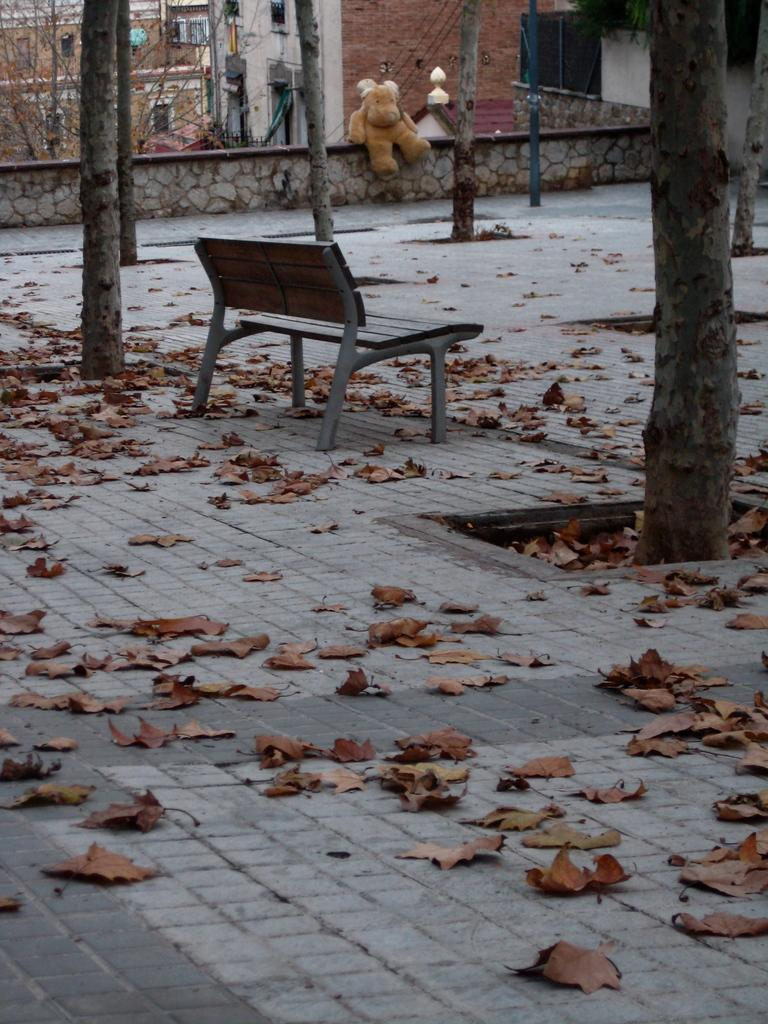What type of seating is present in the image? There is a bench in the image. What can be seen on the ground in the image? Dried leaves are visible in the image. What type of vegetation is present in the image? There are trees in the image. What type of man-made structures are present in the image? There are buildings in the image. What decorative item is present on the wall in the image? There is a doll on the wall in the image. What vertical structures are present in the image? There are poles in the image. What type of winter clothing is being delivered to the address in the image? There is no mention of winter clothing or a delivery in the image. Can you see a scarecrow standing among the trees in the image? There is no scarecrow present in the image; only trees, buildings, and other objects are visible. 